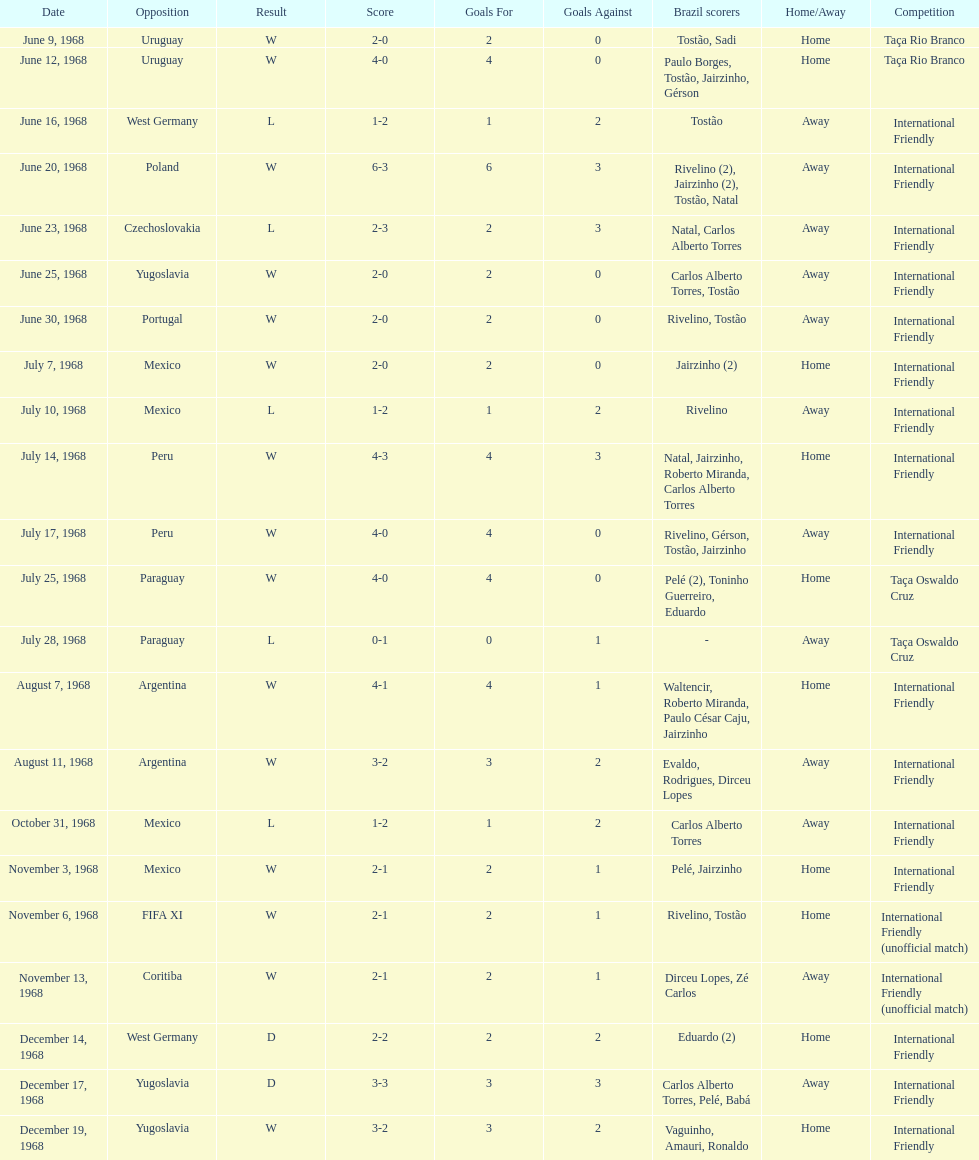In how many games were there wins? 15. 